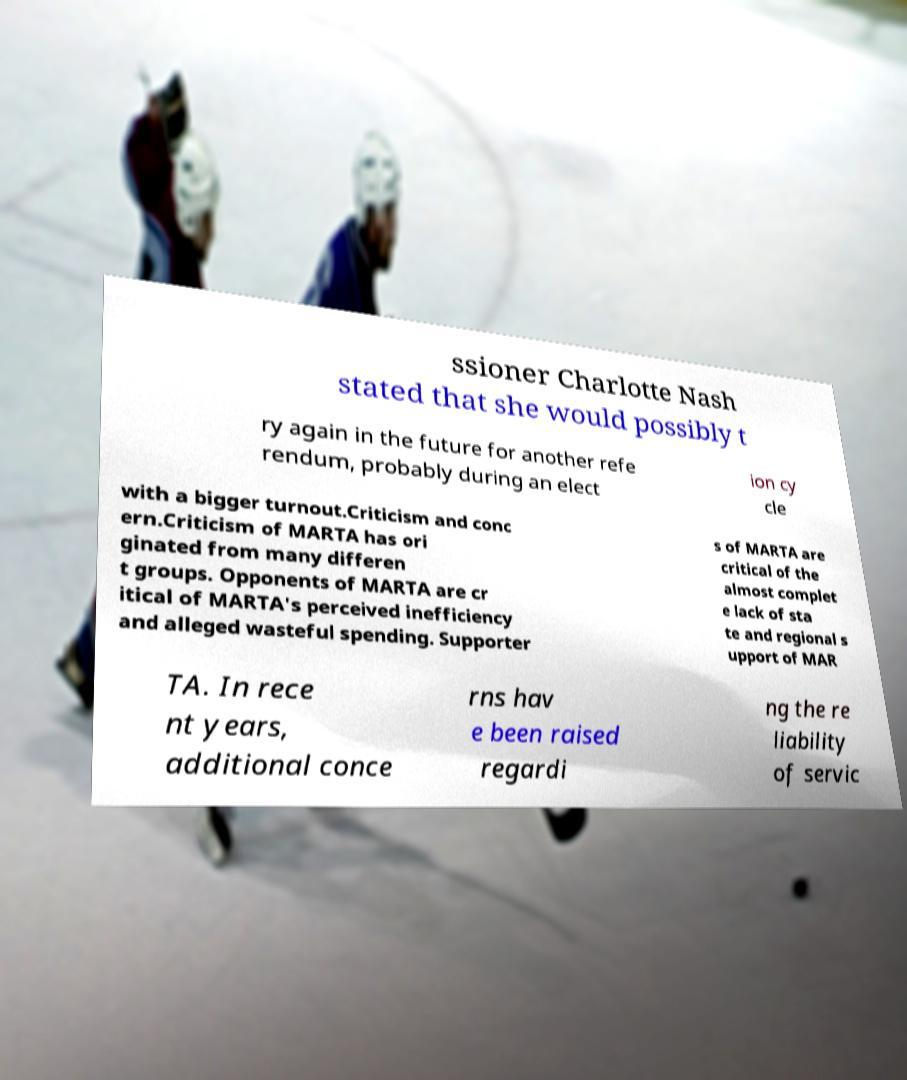Could you assist in decoding the text presented in this image and type it out clearly? ssioner Charlotte Nash stated that she would possibly t ry again in the future for another refe rendum, probably during an elect ion cy cle with a bigger turnout.Criticism and conc ern.Criticism of MARTA has ori ginated from many differen t groups. Opponents of MARTA are cr itical of MARTA's perceived inefficiency and alleged wasteful spending. Supporter s of MARTA are critical of the almost complet e lack of sta te and regional s upport of MAR TA. In rece nt years, additional conce rns hav e been raised regardi ng the re liability of servic 